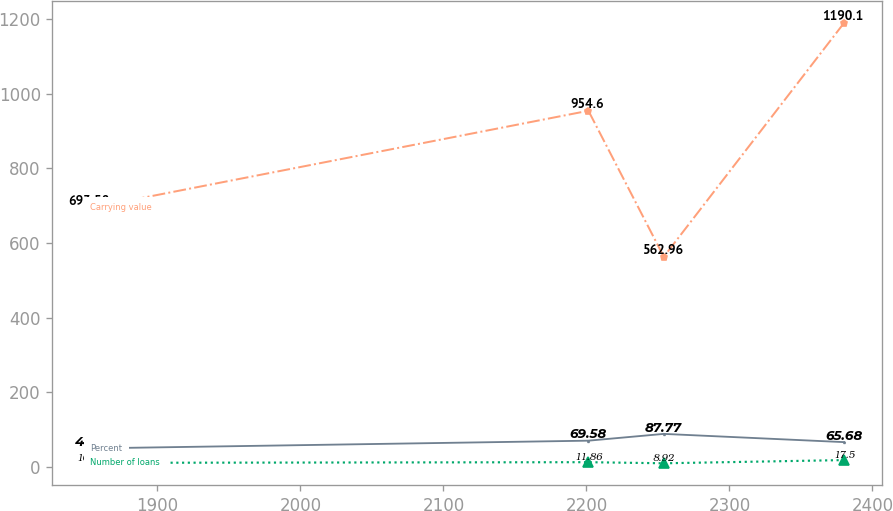<chart> <loc_0><loc_0><loc_500><loc_500><line_chart><ecel><fcel>Percent<fcel>Carrying value<fcel>Number of loans<nl><fcel>1853.04<fcel>48.8<fcel>693.58<fcel>10.14<nl><fcel>2201.39<fcel>69.58<fcel>954.6<fcel>11.86<nl><fcel>2254.09<fcel>87.77<fcel>562.96<fcel>8.92<nl><fcel>2380.09<fcel>65.68<fcel>1190.1<fcel>17.5<nl></chart> 